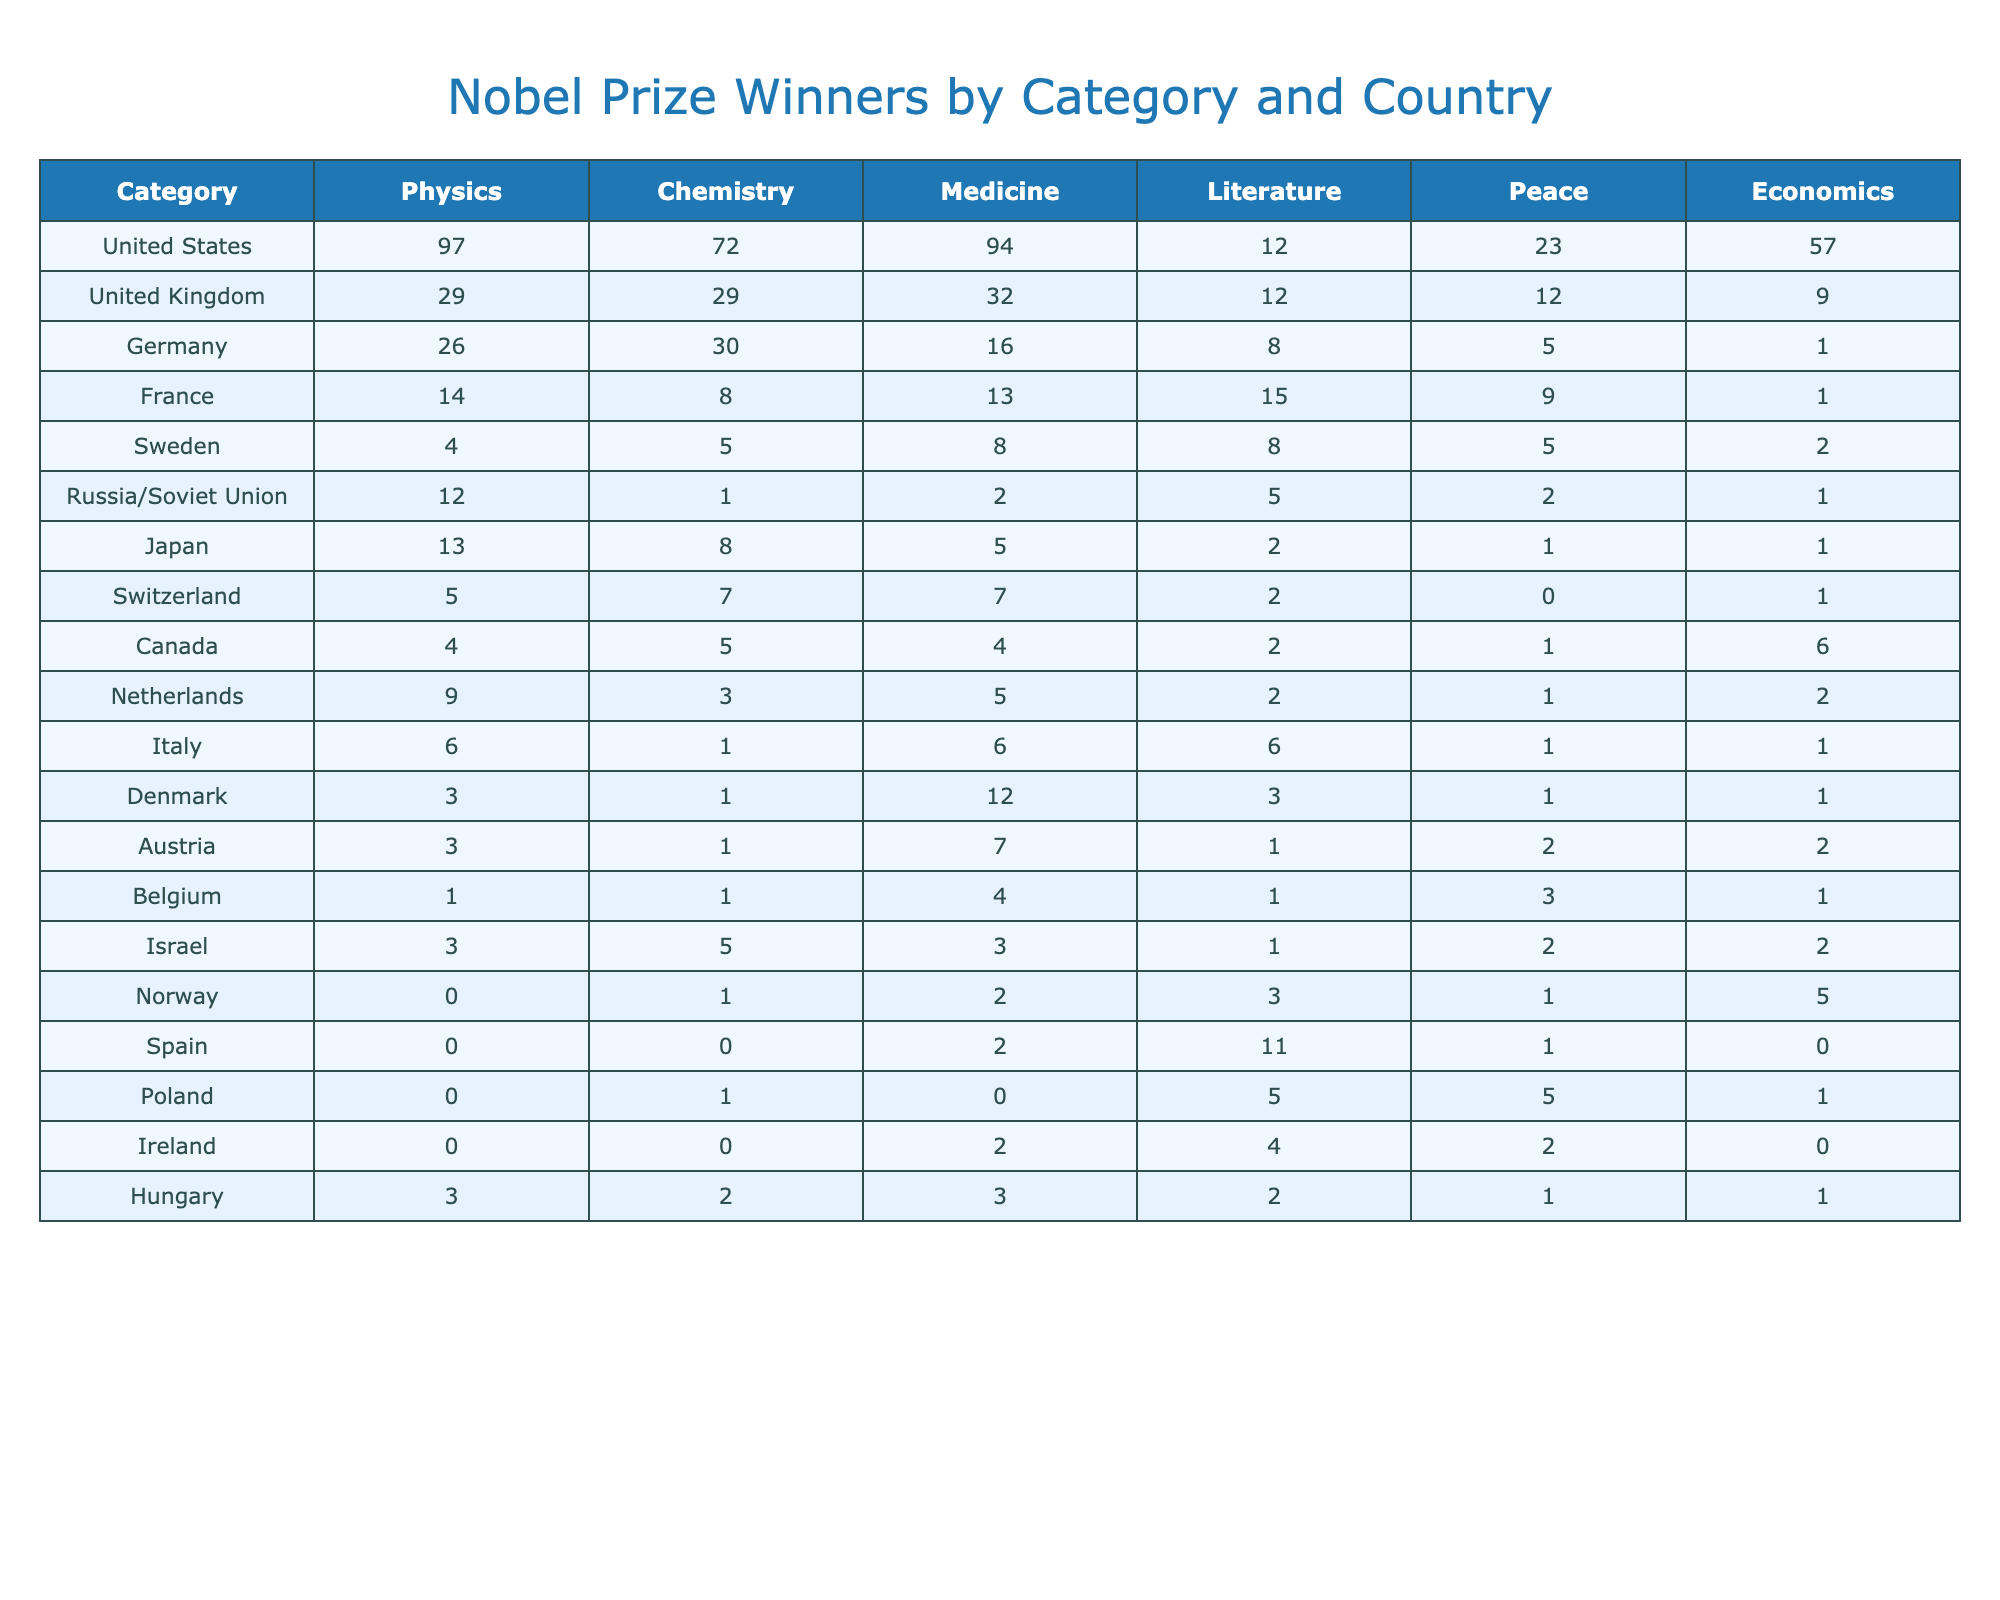What country has the highest number of Nobel Prize winners in Physics? Referring to the table, the United States has 97 Nobel Prize winners in Physics, the highest compared to other countries listed.
Answer: United States How many Nobel Prize winners did Germany have in Chemistry? The table shows that Germany has 30 Nobel Prize winners in Chemistry.
Answer: 30 What is the total number of Nobel Prize winners in Medicine across all countries listed? By summing the values in the Medicine column: (94 + 32 + 16 + 13 + 8 + 2 + 5 + 7 + 4 + 5 + 6 + 12 + 7 + 4 + 3 + 2 + 2 + 0 + 2 + 3) = 300.
Answer: 300 Did Canada receive more Nobel Prizes in Literature than the United Kingdom? Canada has 2 Literature winners, while the United Kingdom also has 12. Therefore, Canada did not receive more.
Answer: No Which country has the least number of Nobel laureates in Peace? Looking at the Peace column, Spain has 0 Nobel laureates, the least among the countries in the table.
Answer: Spain What is the average number of Nobel Prize winners in Economics for the top three performing countries? The top three countries in Economics are the United States (57), the United Kingdom (9), and Germany (1). The total is 67 and the average is 67/3 = 22.33.
Answer: 22.33 How many more Nobel Prize winners did the United States have in Physics compared to the United Kingdom? The United States has 97 in Physics, while the United Kingdom has 29. The difference is 97 - 29 = 68.
Answer: 68 Is it true that more Nobel Prize winners were awarded for Literature than for Chemistry in the United States? In the table, the United States has 12 for Literature and 72 for Chemistry, thus it is false that more were awarded for Literature.
Answer: No What percentage of Nobel Prize winners in Physics are from the United States? The total number of Nobel Prize winners in Physics is 97 (US) + 29 (UK) + 26 (Germany) + 14 (France) + etc. Total = 332. The percentage is (97/332) * 100 = 29.2%.
Answer: 29.2% Which country has the highest total number of Nobel Prize winners across all categories? Summing the totals for the United States (97 + 72 + 94 + 12 + 23 + 57) gives 355, which is the highest total compared to other countries.
Answer: United States 